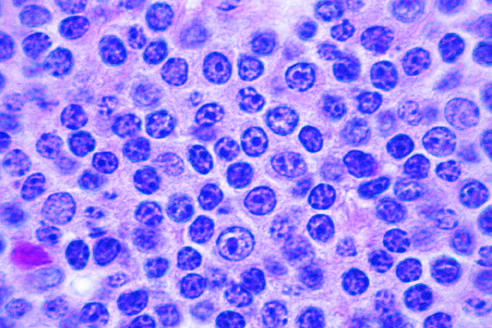what is present in this field?
Answer the question using a single word or phrase. A prolymphocyte 